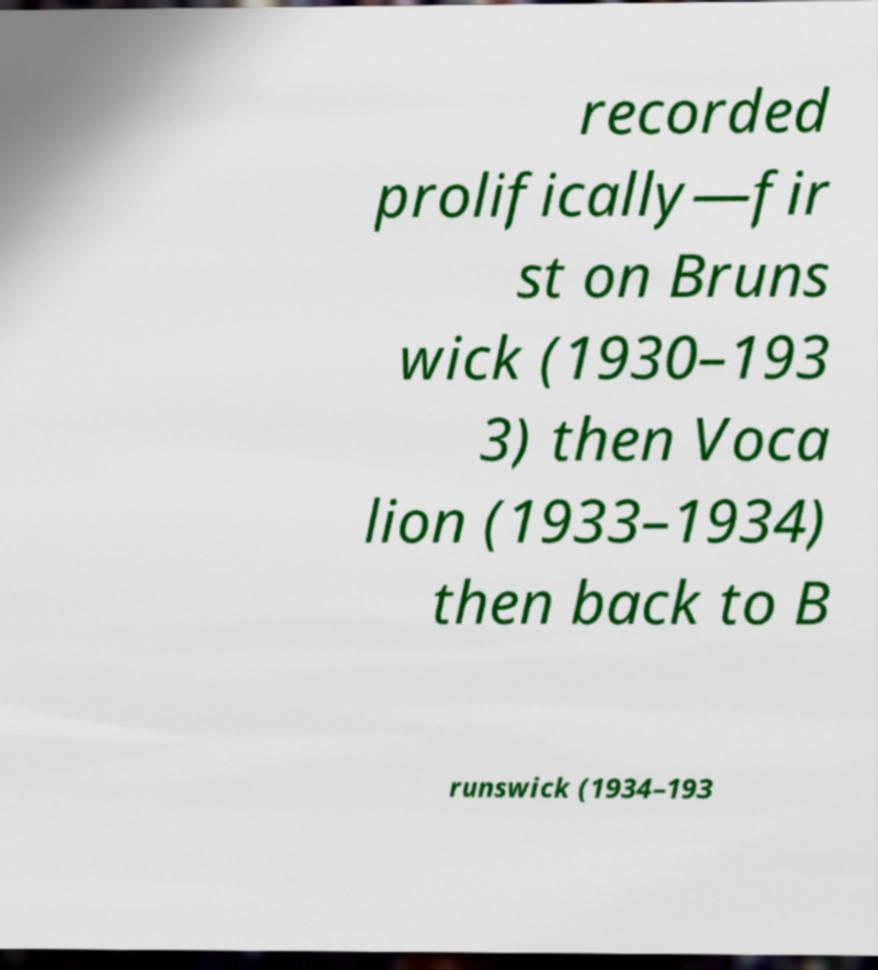Can you accurately transcribe the text from the provided image for me? recorded prolifically—fir st on Bruns wick (1930–193 3) then Voca lion (1933–1934) then back to B runswick (1934–193 